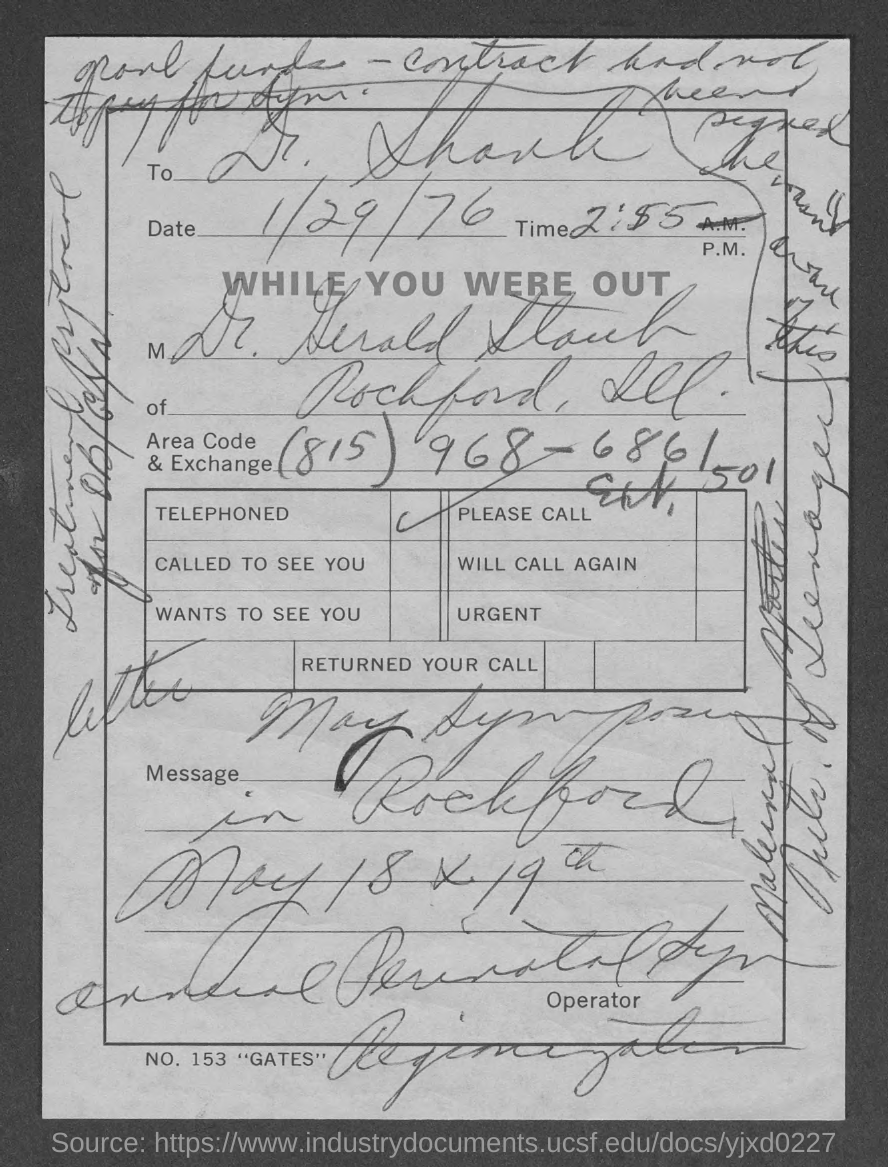What is the date in the document?
Your response must be concise. 1/29/76. What is the area code ?
Keep it short and to the point. 815. 